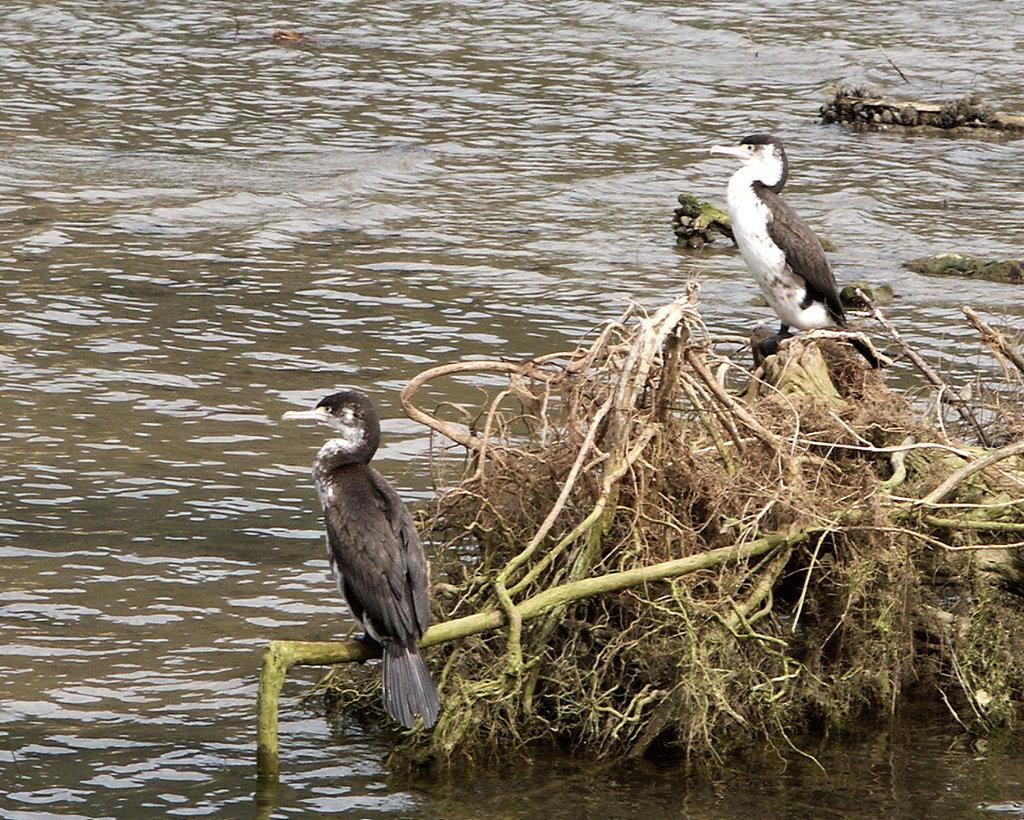How many birds are visible in the image? There are two birds in the image. Where are the birds located in the image? The birds are sitting on the branch of a plant. What can be seen in the background of the image? The background of the image is covered with water. What type of location might the image have been taken in? The image may have been taken near a lake, given the presence of water in the background. What type of house can be seen in the image? There is no house present in the image. 